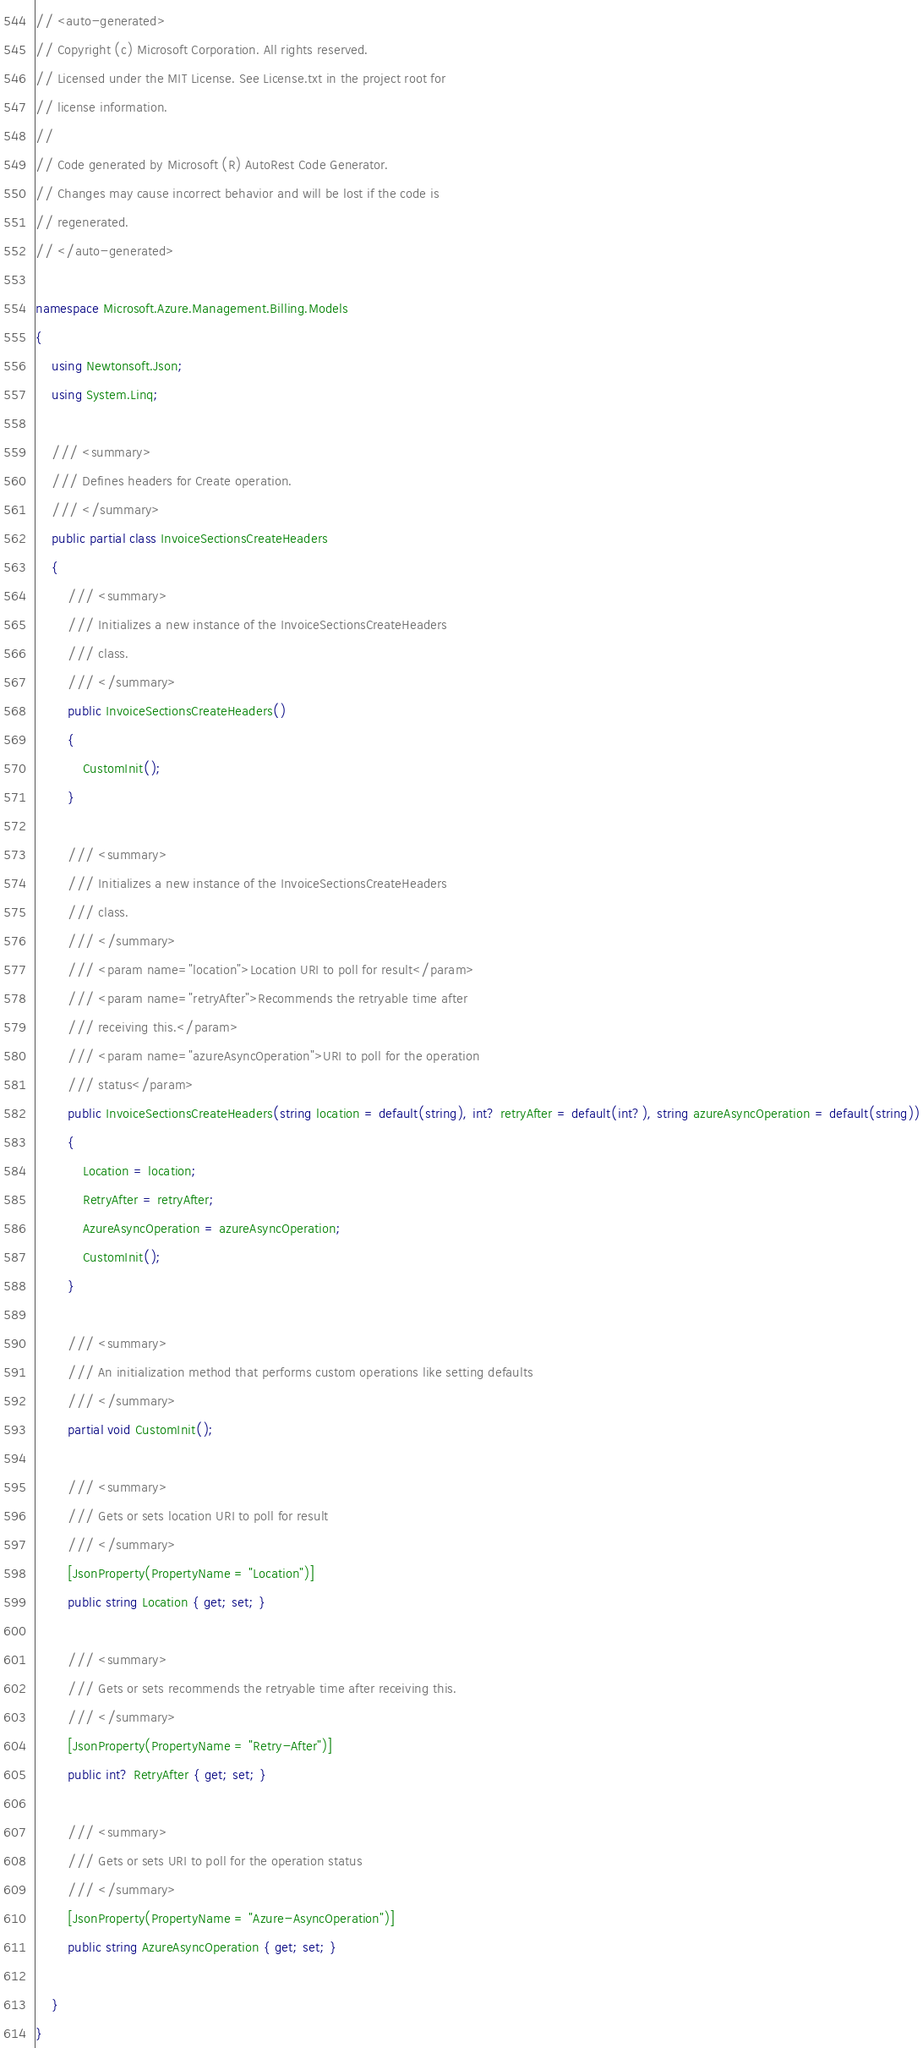<code> <loc_0><loc_0><loc_500><loc_500><_C#_>// <auto-generated>
// Copyright (c) Microsoft Corporation. All rights reserved.
// Licensed under the MIT License. See License.txt in the project root for
// license information.
//
// Code generated by Microsoft (R) AutoRest Code Generator.
// Changes may cause incorrect behavior and will be lost if the code is
// regenerated.
// </auto-generated>

namespace Microsoft.Azure.Management.Billing.Models
{
    using Newtonsoft.Json;
    using System.Linq;

    /// <summary>
    /// Defines headers for Create operation.
    /// </summary>
    public partial class InvoiceSectionsCreateHeaders
    {
        /// <summary>
        /// Initializes a new instance of the InvoiceSectionsCreateHeaders
        /// class.
        /// </summary>
        public InvoiceSectionsCreateHeaders()
        {
            CustomInit();
        }

        /// <summary>
        /// Initializes a new instance of the InvoiceSectionsCreateHeaders
        /// class.
        /// </summary>
        /// <param name="location">Location URI to poll for result</param>
        /// <param name="retryAfter">Recommends the retryable time after
        /// receiving this.</param>
        /// <param name="azureAsyncOperation">URI to poll for the operation
        /// status</param>
        public InvoiceSectionsCreateHeaders(string location = default(string), int? retryAfter = default(int?), string azureAsyncOperation = default(string))
        {
            Location = location;
            RetryAfter = retryAfter;
            AzureAsyncOperation = azureAsyncOperation;
            CustomInit();
        }

        /// <summary>
        /// An initialization method that performs custom operations like setting defaults
        /// </summary>
        partial void CustomInit();

        /// <summary>
        /// Gets or sets location URI to poll for result
        /// </summary>
        [JsonProperty(PropertyName = "Location")]
        public string Location { get; set; }

        /// <summary>
        /// Gets or sets recommends the retryable time after receiving this.
        /// </summary>
        [JsonProperty(PropertyName = "Retry-After")]
        public int? RetryAfter { get; set; }

        /// <summary>
        /// Gets or sets URI to poll for the operation status
        /// </summary>
        [JsonProperty(PropertyName = "Azure-AsyncOperation")]
        public string AzureAsyncOperation { get; set; }

    }
}
</code> 